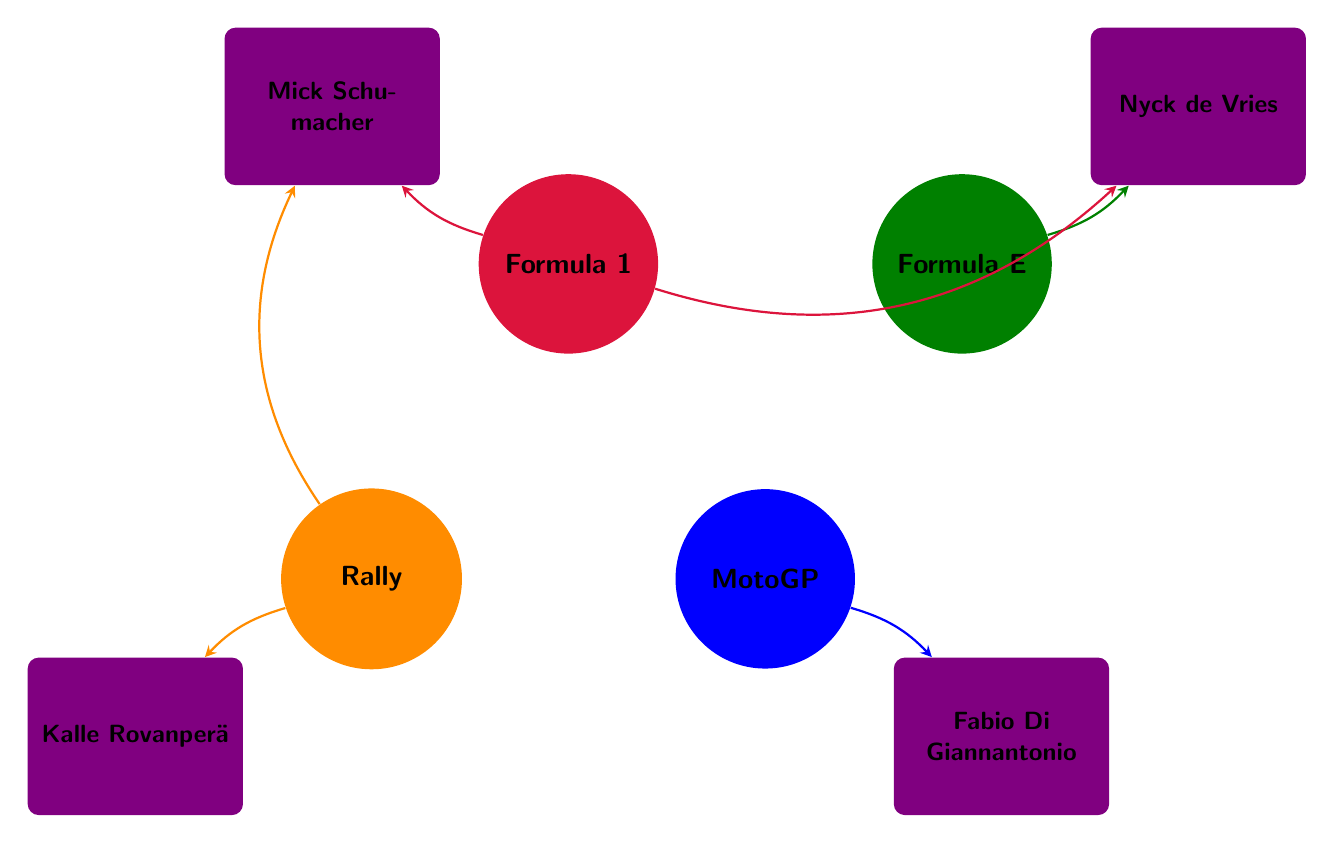What types of motorsport events are represented in the diagram? The diagram includes four nodes representing motorsport events: Formula 1, Formula E, MotoGP, and Rally.
Answer: Formula 1, Formula E, MotoGP, Rally How many emerging talents are linked to Formula 1? From the diagram, there are two emerging talents linked to Formula 1: Mick Schumacher and Nyck de Vries.
Answer: 2 Which emerging talent is associated with MotoGP? The diagram shows that Fabio Di Giannantonio is the only emerging talent connected to MotoGP.
Answer: Fabio Di Giannantonio Which motorsport event is Kalle Rovanperä linked to? The diagram indicates that Kalle Rovanperä is linked to the Rally event.
Answer: Rally How many talents are associated with Rally? The diagram depicts two emerging talents connected to the Rally: Kalle Rovanperä and Mick Schumacher.
Answer: 2 Is Nyck de Vries linked to more than one motorsport event? Yes, the diagram shows that Nyck de Vries is linked to both Formula E and Formula 1 events.
Answer: Yes What color represents Formula E in the diagram? Formula E is represented by the green color in the diagram.
Answer: Green Which talent is linked to Rally in addition to Mick Schumacher? The diagram indicates that Kalle Rovanperä is linked to Rally, alongside Mick Schumacher.
Answer: Kalle Rovanperä What is the relationship between Formula E and Nyck de Vries? The diagram shows a direct link from Formula E to Nyck de Vries, indicating that he is associated with this motorsport event.
Answer: Linked 